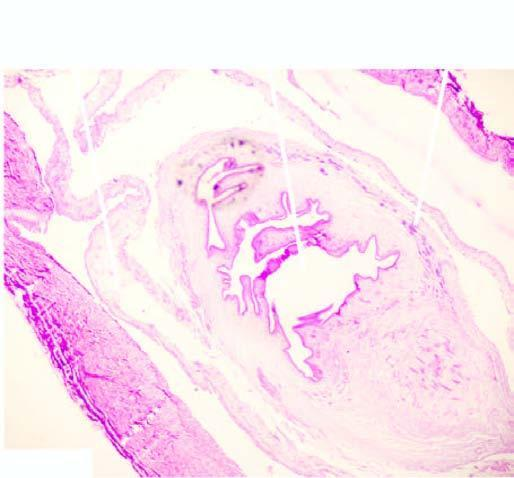what shows palisade layer of histiocytes?
Answer the question using a single word or phrase. Cyst wall 